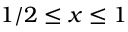<formula> <loc_0><loc_0><loc_500><loc_500>1 / 2 \leq x \leq 1</formula> 